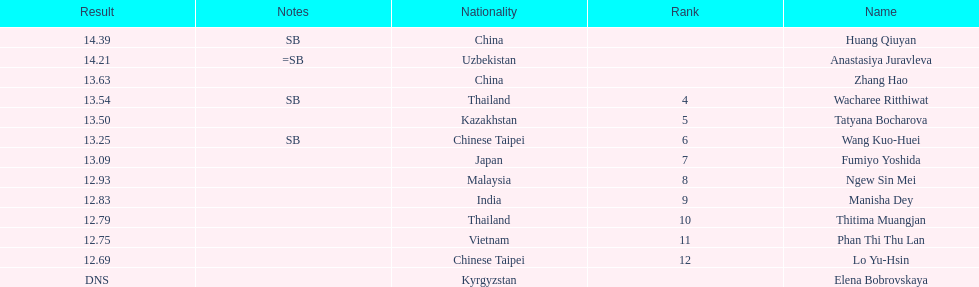How many people were ranked? 12. 